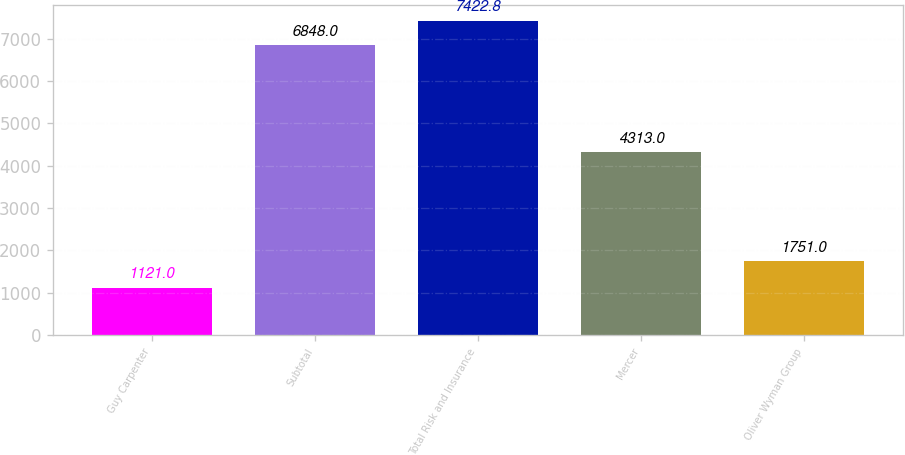<chart> <loc_0><loc_0><loc_500><loc_500><bar_chart><fcel>Guy Carpenter<fcel>Subtotal<fcel>Total Risk and Insurance<fcel>Mercer<fcel>Oliver Wyman Group<nl><fcel>1121<fcel>6848<fcel>7422.8<fcel>4313<fcel>1751<nl></chart> 